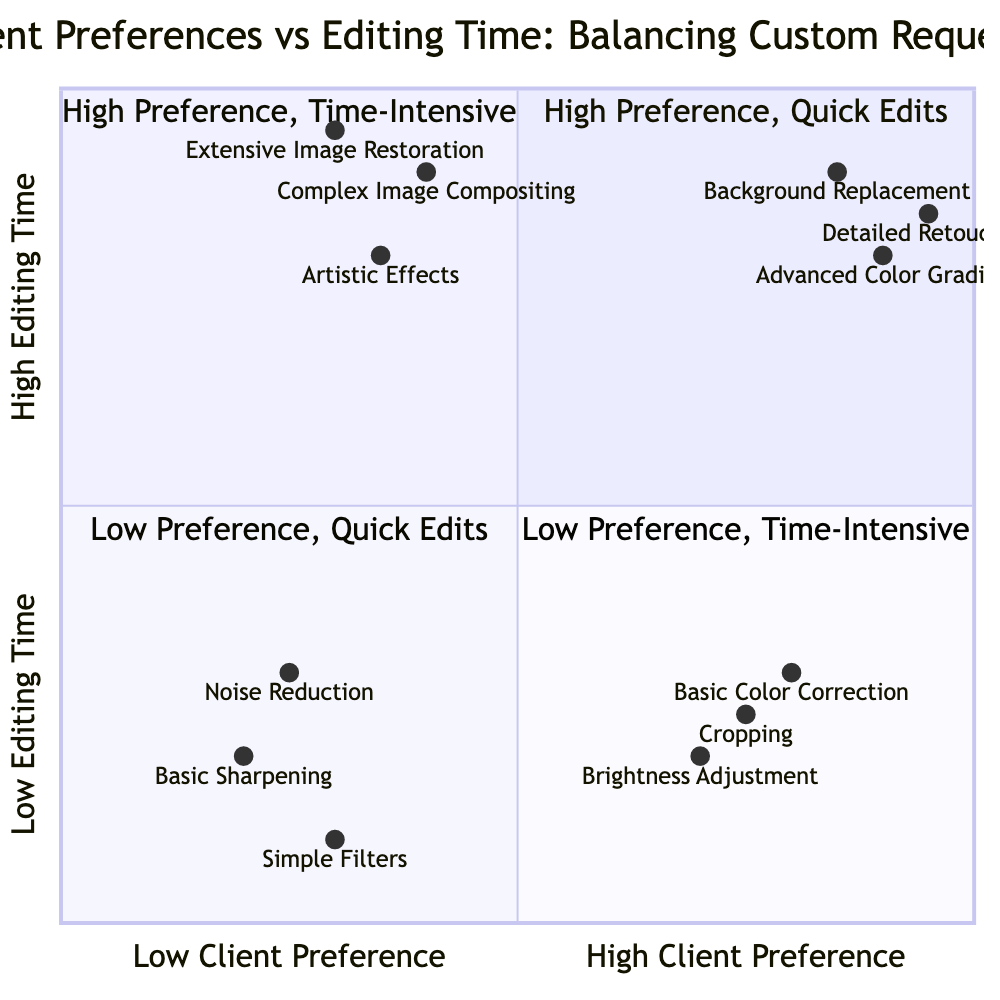What is the feature in Quadrant 1 with the highest client preference? Quadrant 1 contains three features: Brightness Adjustment, Basic Color Correction, and Cropping. Among these, Basic Color Correction has the highest client preference value of 0.8.
Answer: Basic Color Correction How many features are listed in Quadrant 4? Quadrant 4 includes three features: Complex Image Compositing, Artistic Effects, and Extensive Image Restoration. Therefore, the total count is three.
Answer: Three What is the editing time for Advanced Color Grading? Advanced Color Grading is located in Quadrant 2, which indicates a high editing time. The specific value for editing time is 0.8.
Answer: 0.8 In which quadrant does Basic Sharpening reside? Basic Sharpening is located in Quadrant 3, which corresponds to low client preference and low editing time.
Answer: Quadrant 3 Which feature has the lowest client preference in Quadrant 4? Quadrant 4 consists of Complex Image Compositing, Artistic Effects, and Extensive Image Restoration. Among these, Extensive Image Restoration has the lowest client preference value of 0.3.
Answer: Extensive Image Restoration What is the relationship between Background Replacement and Detailed Retouching? Background Replacement is in Quadrant 2 with a high client preference and high editing time, while Detailed Retouching is also in Quadrant 2 with an even higher client preference value of 0.95. Both have high editing time, indicating they share similar demands from clients.
Answer: High preference, high editing time Which editing feature requires the most editing time in the chart? Examining all listed features, Detailed Retouching is located in Quadrant 2 and has an editing time of 0.85. This is the maximum value for editing time among features in the chart.
Answer: 0.85 Which quadrant features simple filters and basic sharpening? Both of these features are positioned in Quadrant 3, which signifies low client preference and low editing time.
Answer: Quadrant 3 